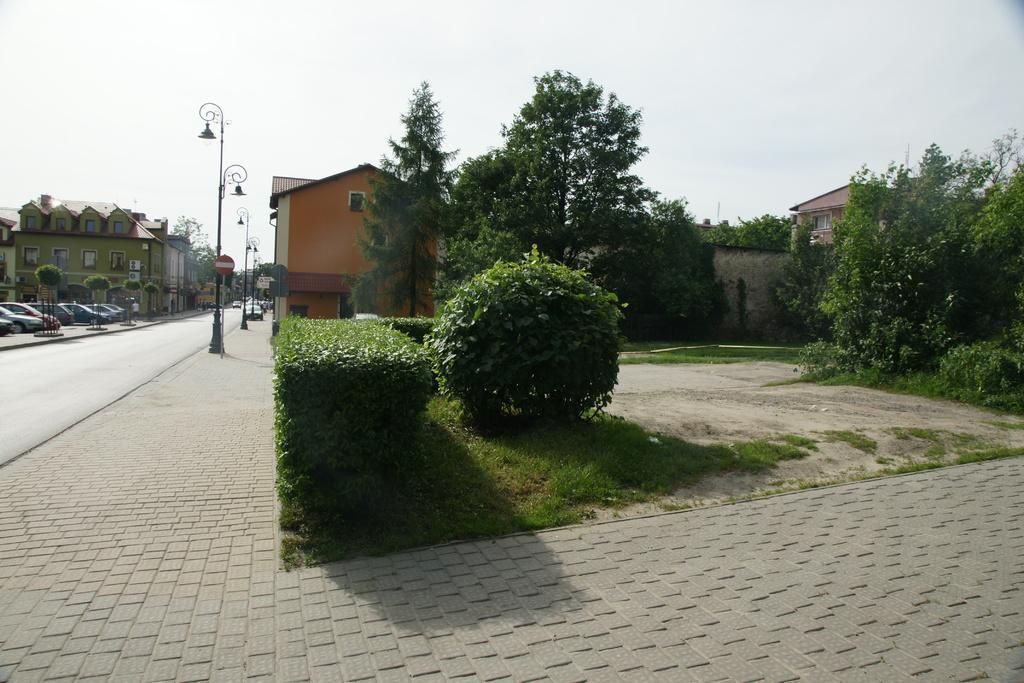Could you give a brief overview of what you see in this image? In the background I can see the grass, trees and buildings. In the background I can see vehicles, streetlights and the sky. 